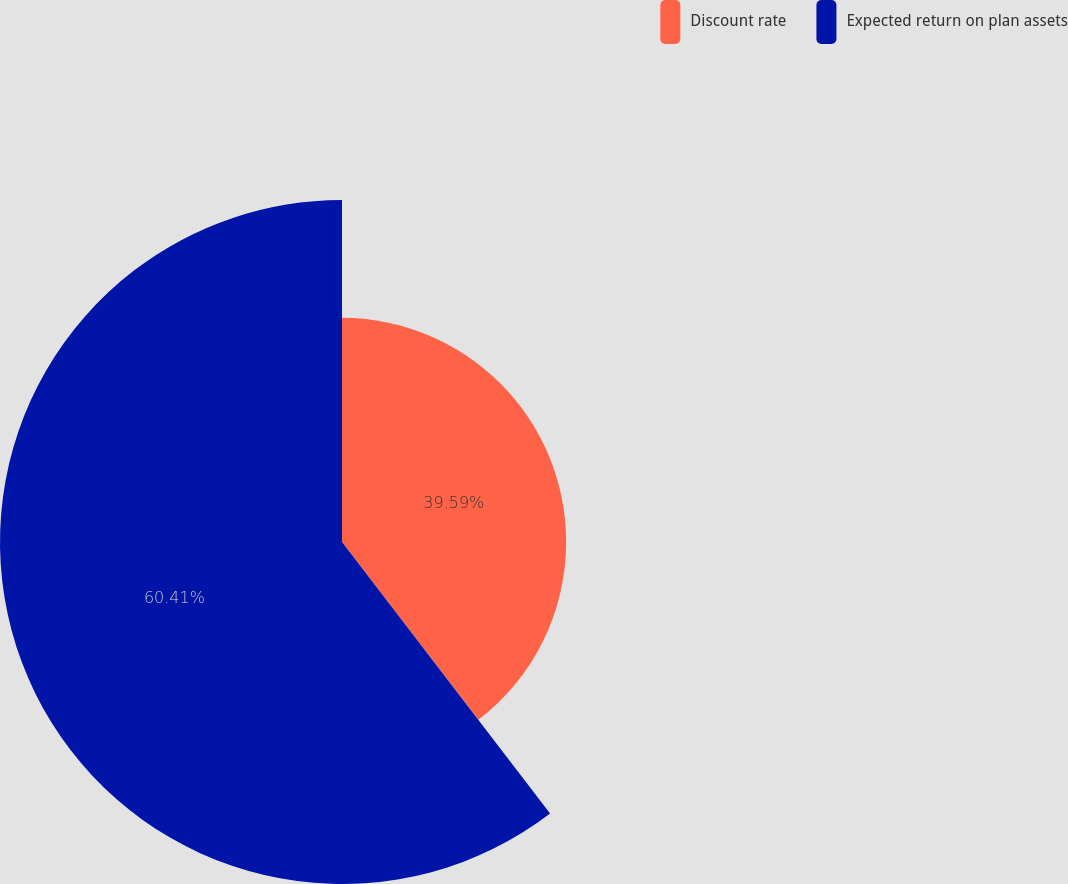<chart> <loc_0><loc_0><loc_500><loc_500><pie_chart><fcel>Discount rate<fcel>Expected return on plan assets<nl><fcel>39.59%<fcel>60.41%<nl></chart> 